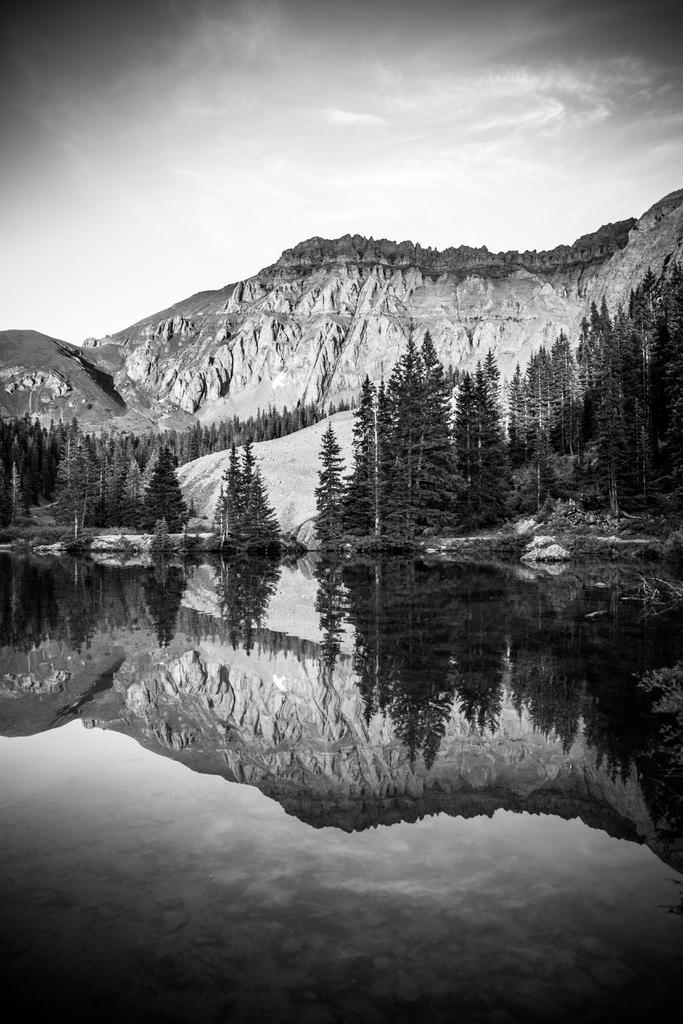What is the main feature in the foreground of the image? There is a water body in the foreground of the image. What does the water body do in relation to the mountain and trees? The water body reflects the mountain and trees. What can be seen in the background of the image? There is a mountain and trees in the background of the image. What type of stem can be seen growing from the water body in the image? There is no stem visible in the image; it features a water body, mountain, and trees. How does the scarecrow interact with the water body in the image? There is no scarecrow present in the image, so it cannot interact with the water body. 